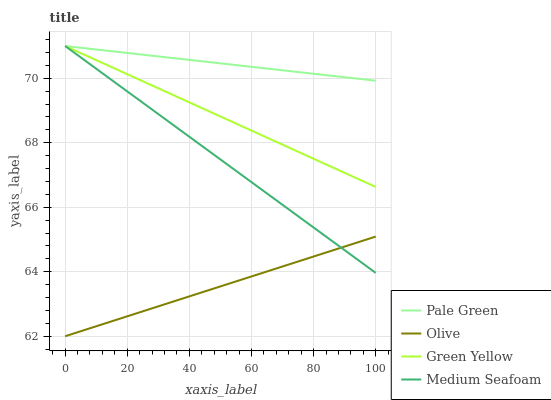Does Olive have the minimum area under the curve?
Answer yes or no. Yes. Does Pale Green have the maximum area under the curve?
Answer yes or no. Yes. Does Green Yellow have the minimum area under the curve?
Answer yes or no. No. Does Green Yellow have the maximum area under the curve?
Answer yes or no. No. Is Green Yellow the smoothest?
Answer yes or no. Yes. Is Medium Seafoam the roughest?
Answer yes or no. Yes. Is Pale Green the smoothest?
Answer yes or no. No. Is Pale Green the roughest?
Answer yes or no. No. Does Olive have the lowest value?
Answer yes or no. Yes. Does Green Yellow have the lowest value?
Answer yes or no. No. Does Medium Seafoam have the highest value?
Answer yes or no. Yes. Is Olive less than Green Yellow?
Answer yes or no. Yes. Is Pale Green greater than Olive?
Answer yes or no. Yes. Does Green Yellow intersect Pale Green?
Answer yes or no. Yes. Is Green Yellow less than Pale Green?
Answer yes or no. No. Is Green Yellow greater than Pale Green?
Answer yes or no. No. Does Olive intersect Green Yellow?
Answer yes or no. No. 